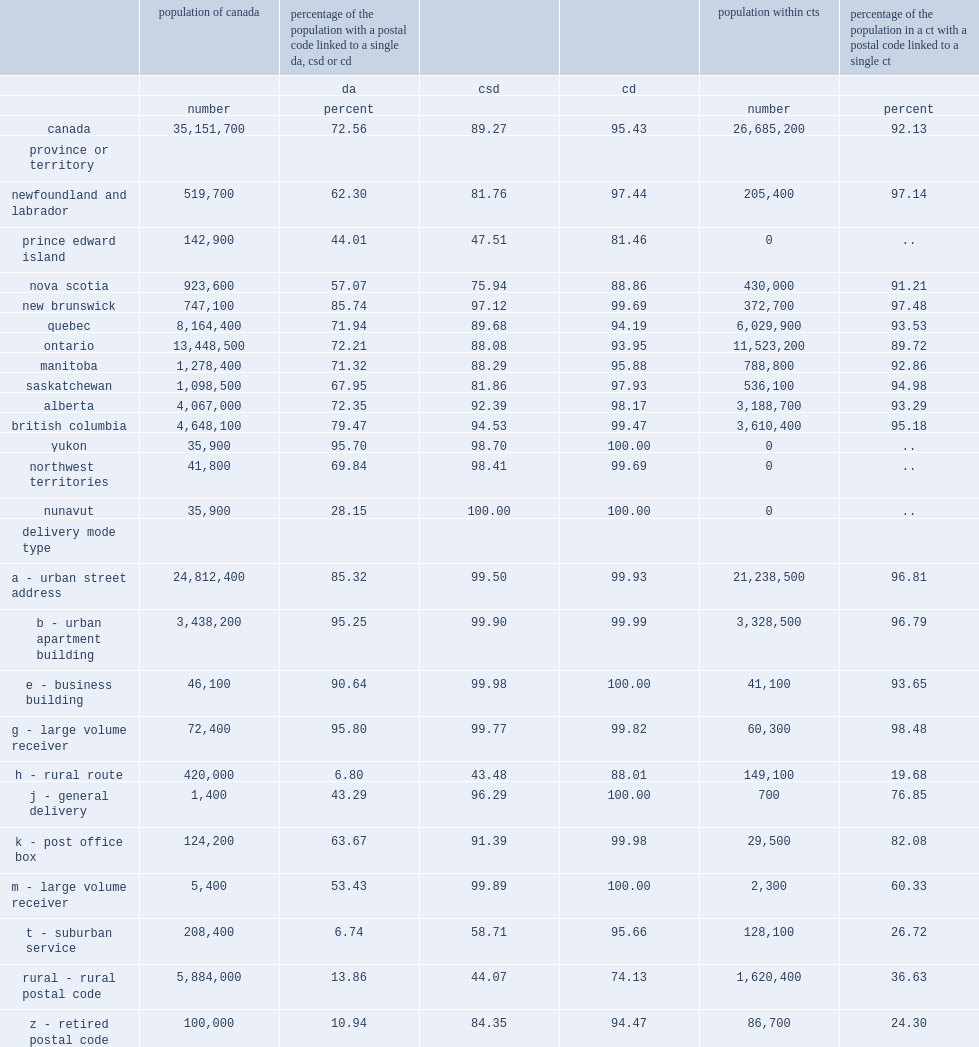In general, most of the population was matched to a single csd, what is the percentage in prince edward island ? 47.51. In general, most of the population was matched to a single csd, what is the percentage in nova scotia ? 75.94. In general, most of the population was matched to a single csd, what is the percentage of population centres outside a cma or ca ? 67.85. What is the proportion of the population matched to a single csd was considerably lower for dmts of types h? 43.48. What is the proportion of the population matched to a single csd was considerably lower for dmts of rural ? 44.07. How many canadians were matched to a ct? 26685200.0. What is the percentage of canadians were matched to a ct? 92.13. 